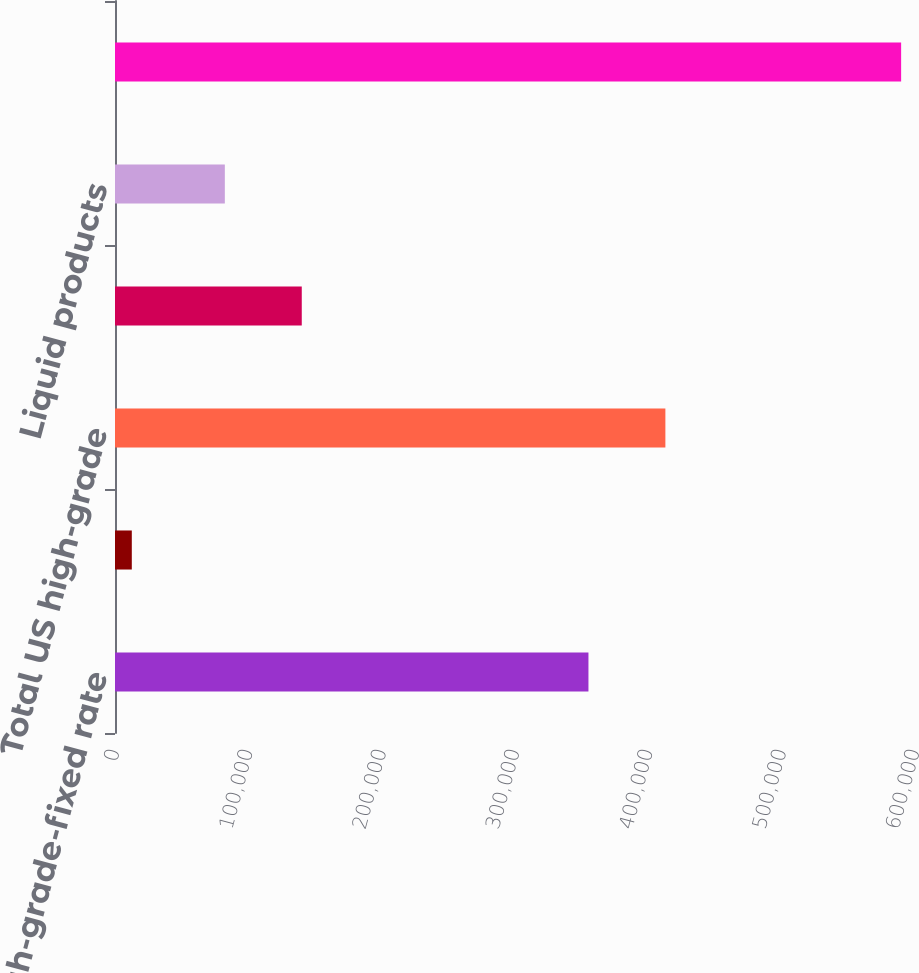<chart> <loc_0><loc_0><loc_500><loc_500><bar_chart><fcel>US high-grade-fixed rate<fcel>US high-grade-floating rate<fcel>Total US high-grade<fcel>Other credit<fcel>Liquid products<fcel>Total<nl><fcel>355087<fcel>12603<fcel>412786<fcel>140079<fcel>82380<fcel>589596<nl></chart> 